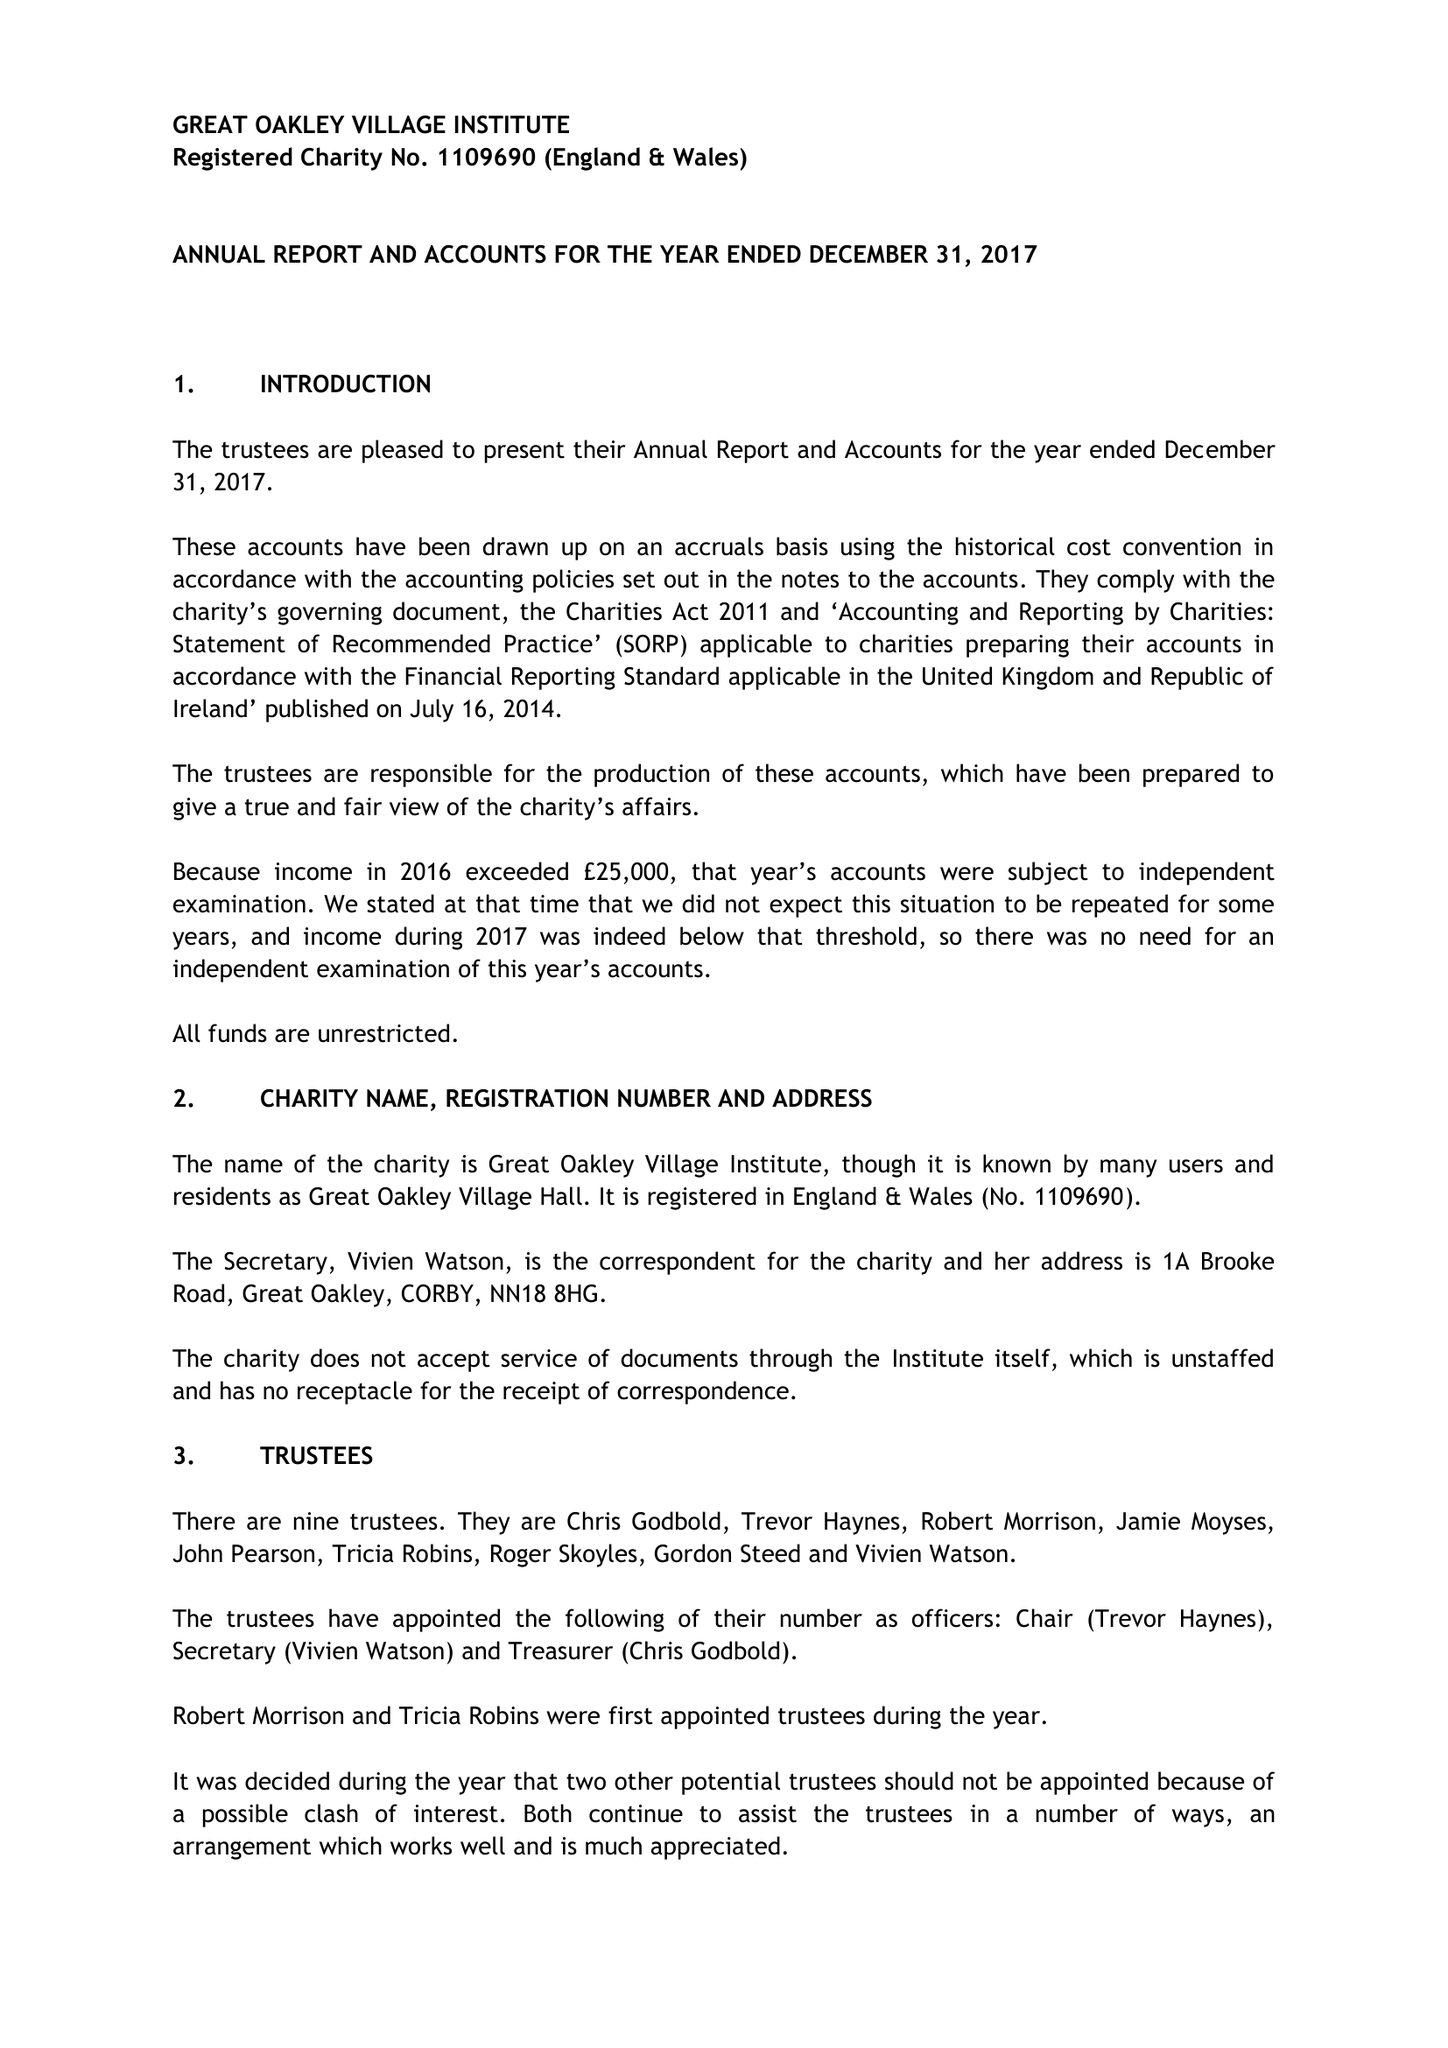What is the value for the address__post_town?
Answer the question using a single word or phrase. CORBY 